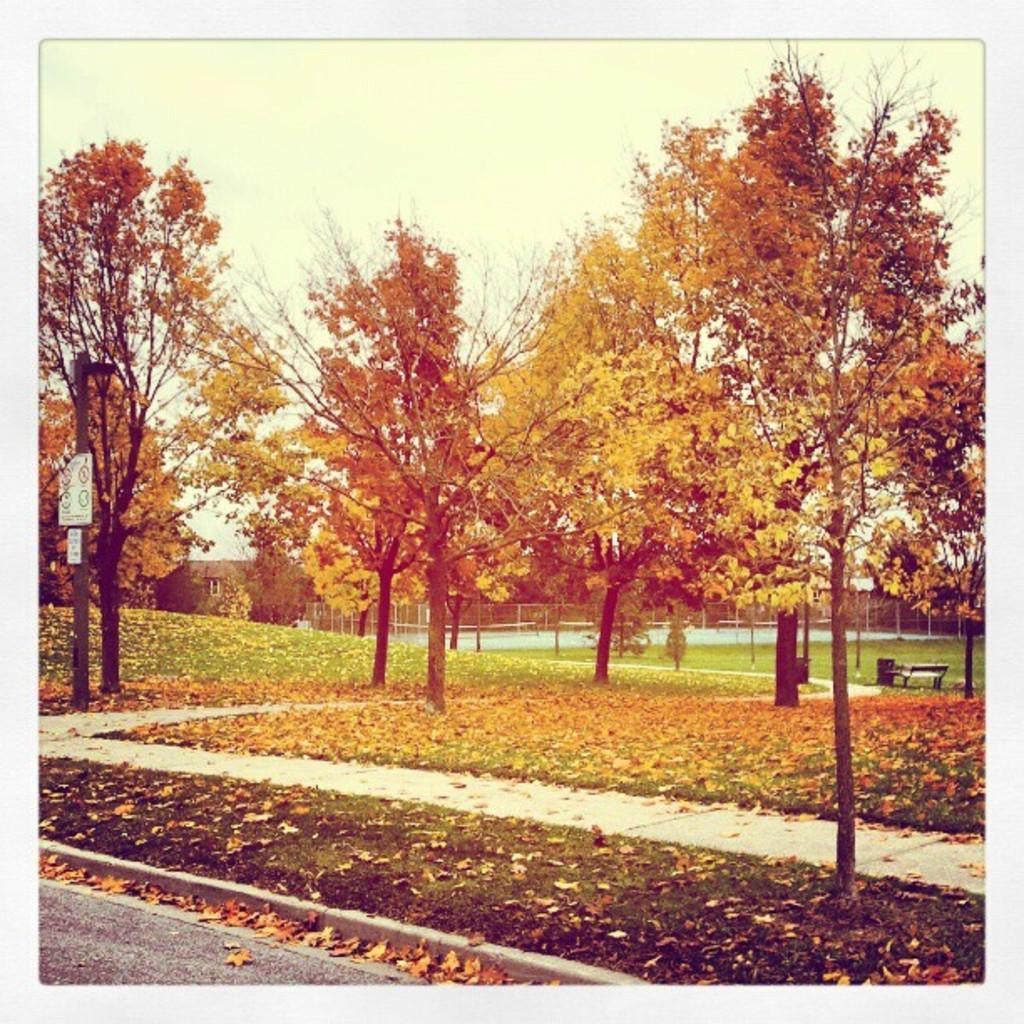What can be seen in the foreground of the image? In the foreground of the image, there are trees, grassland, and a pole. What is visible in the background of the image? In the background of the image, there are houses, boundaries, a bench, and the sky. Can you describe the vegetation in the foreground? The vegetation in the foreground consists of trees and grassland. What type of structure is present in the background? There is a bench in the background of the image. How many women are sitting on the leg in the image? There are no women or legs present in the image. What type of respect is shown by the trees in the image? The trees in the image do not show any form of respect, as they are inanimate objects. 